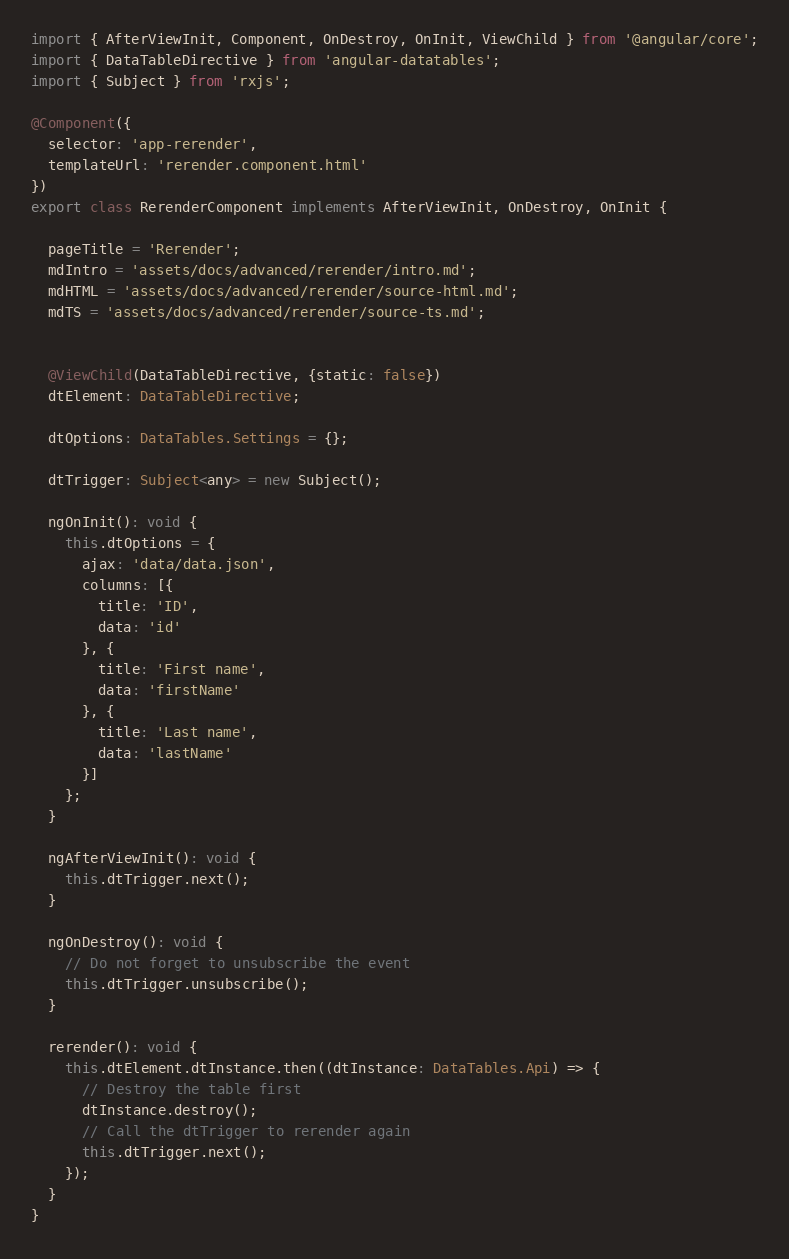<code> <loc_0><loc_0><loc_500><loc_500><_TypeScript_>import { AfterViewInit, Component, OnDestroy, OnInit, ViewChild } from '@angular/core';
import { DataTableDirective } from 'angular-datatables';
import { Subject } from 'rxjs';

@Component({
  selector: 'app-rerender',
  templateUrl: 'rerender.component.html'
})
export class RerenderComponent implements AfterViewInit, OnDestroy, OnInit {

  pageTitle = 'Rerender';
  mdIntro = 'assets/docs/advanced/rerender/intro.md';
  mdHTML = 'assets/docs/advanced/rerender/source-html.md';
  mdTS = 'assets/docs/advanced/rerender/source-ts.md';


  @ViewChild(DataTableDirective, {static: false})
  dtElement: DataTableDirective;

  dtOptions: DataTables.Settings = {};

  dtTrigger: Subject<any> = new Subject();

  ngOnInit(): void {
    this.dtOptions = {
      ajax: 'data/data.json',
      columns: [{
        title: 'ID',
        data: 'id'
      }, {
        title: 'First name',
        data: 'firstName'
      }, {
        title: 'Last name',
        data: 'lastName'
      }]
    };
  }

  ngAfterViewInit(): void {
    this.dtTrigger.next();
  }

  ngOnDestroy(): void {
    // Do not forget to unsubscribe the event
    this.dtTrigger.unsubscribe();
  }

  rerender(): void {
    this.dtElement.dtInstance.then((dtInstance: DataTables.Api) => {
      // Destroy the table first
      dtInstance.destroy();
      // Call the dtTrigger to rerender again
      this.dtTrigger.next();
    });
  }
}
</code> 